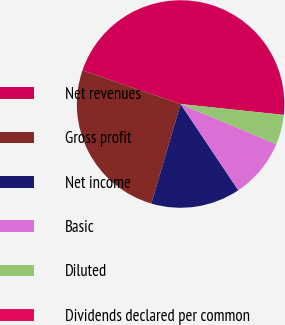Convert chart. <chart><loc_0><loc_0><loc_500><loc_500><pie_chart><fcel>Net revenues<fcel>Gross profit<fcel>Net income<fcel>Basic<fcel>Diluted<fcel>Dividends declared per common<nl><fcel>46.44%<fcel>25.69%<fcel>13.93%<fcel>9.29%<fcel>4.65%<fcel>0.0%<nl></chart> 